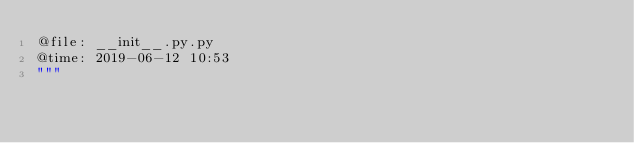Convert code to text. <code><loc_0><loc_0><loc_500><loc_500><_Python_>@file: __init__.py.py
@time: 2019-06-12 10:53
"""</code> 